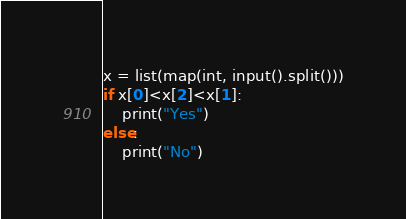<code> <loc_0><loc_0><loc_500><loc_500><_Python_>x = list(map(int, input().split()))
if x[0]<x[2]<x[1]:
    print("Yes")
else:
    print("No")</code> 